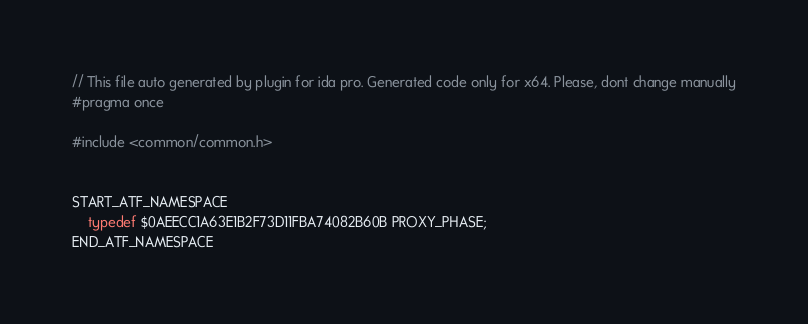<code> <loc_0><loc_0><loc_500><loc_500><_C++_>// This file auto generated by plugin for ida pro. Generated code only for x64. Please, dont change manually
#pragma once

#include <common/common.h>


START_ATF_NAMESPACE
    typedef $0AEECC1A63E1B2F73D11FBA74082B60B PROXY_PHASE;
END_ATF_NAMESPACE
</code> 